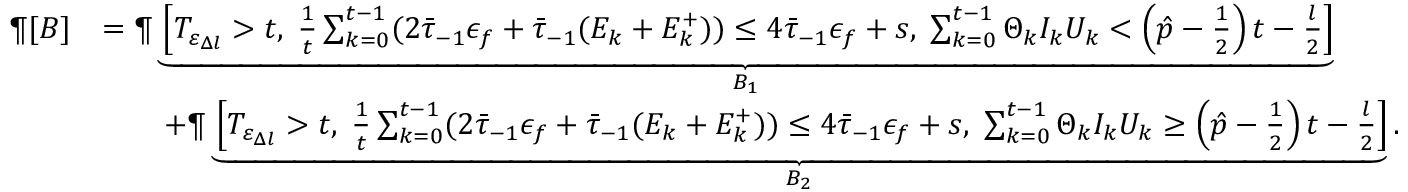<formula> <loc_0><loc_0><loc_500><loc_500>\begin{array} { r l } { \P [ B ] } & { = \P \underbrace { \left [ T _ { \varepsilon _ { \Delta l } } > t , \, \frac { 1 } { t } \sum _ { k = 0 } ^ { t - 1 } ( 2 \bar { \tau } _ { - 1 } \epsilon _ { f } + \bar { \tau } _ { - 1 } ( E _ { k } + E _ { k } ^ { + } ) ) \leq 4 \bar { \tau } _ { - 1 } \epsilon _ { f } + s , \, \sum _ { k = 0 } ^ { t - 1 } \Theta _ { k } I _ { k } U _ { k } < \left ( \hat { p } - \frac { 1 } { 2 } \right ) t - \frac { l } { 2 } \right ] } _ { B _ { 1 } } } \\ & { \quad + \P \underbrace { \left [ T _ { \varepsilon _ { \Delta l } } > t , \, \frac { 1 } { t } \sum _ { k = 0 } ^ { t - 1 } ( 2 \bar { \tau } _ { - 1 } \epsilon _ { f } + \bar { \tau } _ { - 1 } ( E _ { k } + E _ { k } ^ { + } ) ) \leq 4 \bar { \tau } _ { - 1 } \epsilon _ { f } + s , \, \sum _ { k = 0 } ^ { t - 1 } \Theta _ { k } I _ { k } U _ { k } \geq \left ( \hat { p } - \frac { 1 } { 2 } \right ) t - \frac { l } { 2 } \right ] } _ { B _ { 2 } } . } \end{array}</formula> 